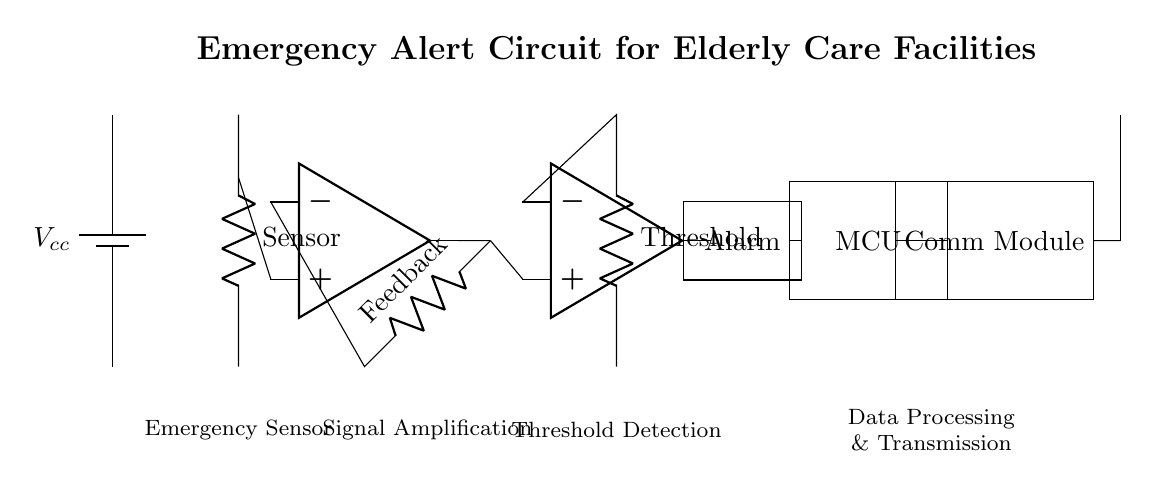What is the main purpose of the emergency alert circuit? The circuit is designed to detect emergencies in elderly care facilities, sending an alert for assistance when needed.
Answer: Emergency alert What type of sensor is used in this circuit? The circuit contains a sensor to detect emergencies, likely a type of emergency sensor that's sensitive to specific conditions such as motion or vital signs.
Answer: Emergency sensor How does the alert get transmitted? The signal travels from the microcontroller to the communication module, which then sends the alert via an antenna, ensuring it reaches the intended recipients.
Answer: Via communication module and antenna What component is responsible for signal amplification? The operational amplifier acts as the amplifying element, boosting the signal strength from the sensor before it moves to other stages of the circuit.
Answer: Operational amplifier What is the function of the comparator in this circuit? The comparator compares the input signal from the amplifier to a predefined threshold level to determine if the signal indicates an emergency condition or not.
Answer: Threshold detection How is the alarm connected within this circuit? The alarm activates upon receiving a signal from the comparator when it senses that the input exceeds a designated threshold, indicating an emergency has been detected.
Answer: From comparator to alarm What does MCU stand for in this context? The MCU stands for microcontroller unit, which processes the signal received from the sensor and determines the appropriate action, including triggering the alarm and transmitting data.
Answer: Microcontroller unit 